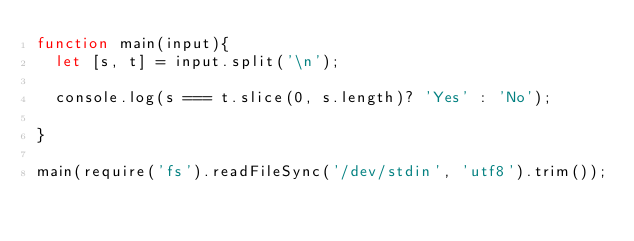<code> <loc_0><loc_0><loc_500><loc_500><_JavaScript_>function main(input){
  let [s, t] = input.split('\n');
  
  console.log(s === t.slice(0, s.length)? 'Yes' : 'No');
  
}

main(require('fs').readFileSync('/dev/stdin', 'utf8').trim());</code> 